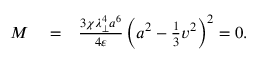Convert formula to latex. <formula><loc_0><loc_0><loc_500><loc_500>\begin{array} { r l r } { M } & = } & { \frac { 3 \chi \lambda _ { \perp } ^ { 4 } a ^ { 6 } } { 4 \varepsilon } \left ( a ^ { 2 } - \frac { 1 } { 3 } v ^ { 2 } \right ) ^ { 2 } = 0 . } \end{array}</formula> 